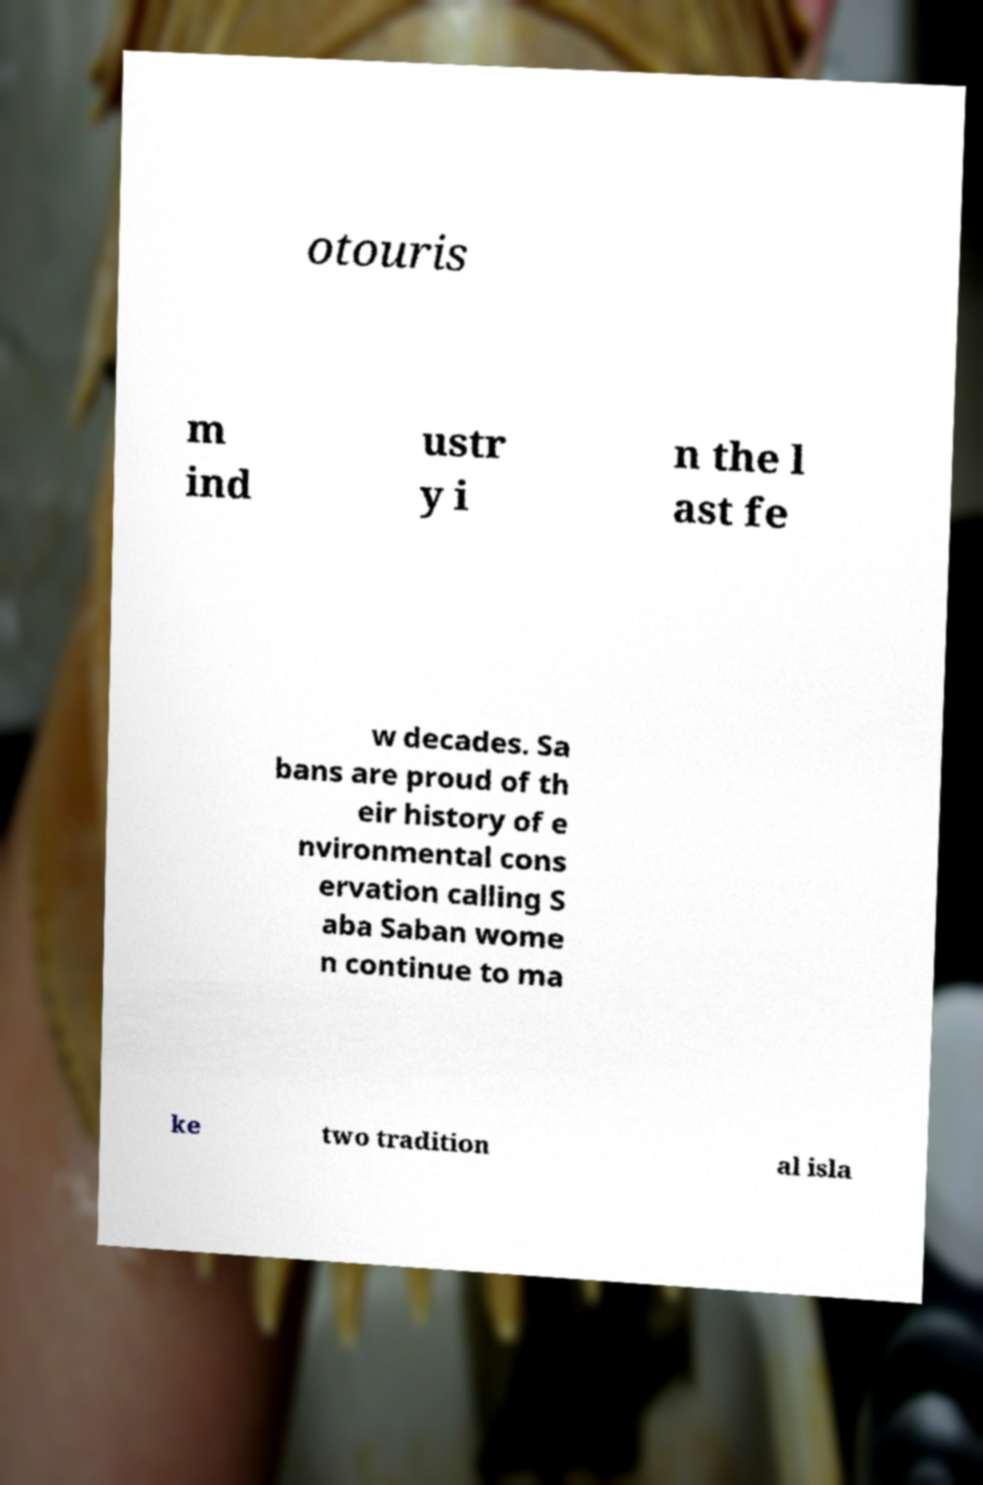Can you read and provide the text displayed in the image?This photo seems to have some interesting text. Can you extract and type it out for me? otouris m ind ustr y i n the l ast fe w decades. Sa bans are proud of th eir history of e nvironmental cons ervation calling S aba Saban wome n continue to ma ke two tradition al isla 